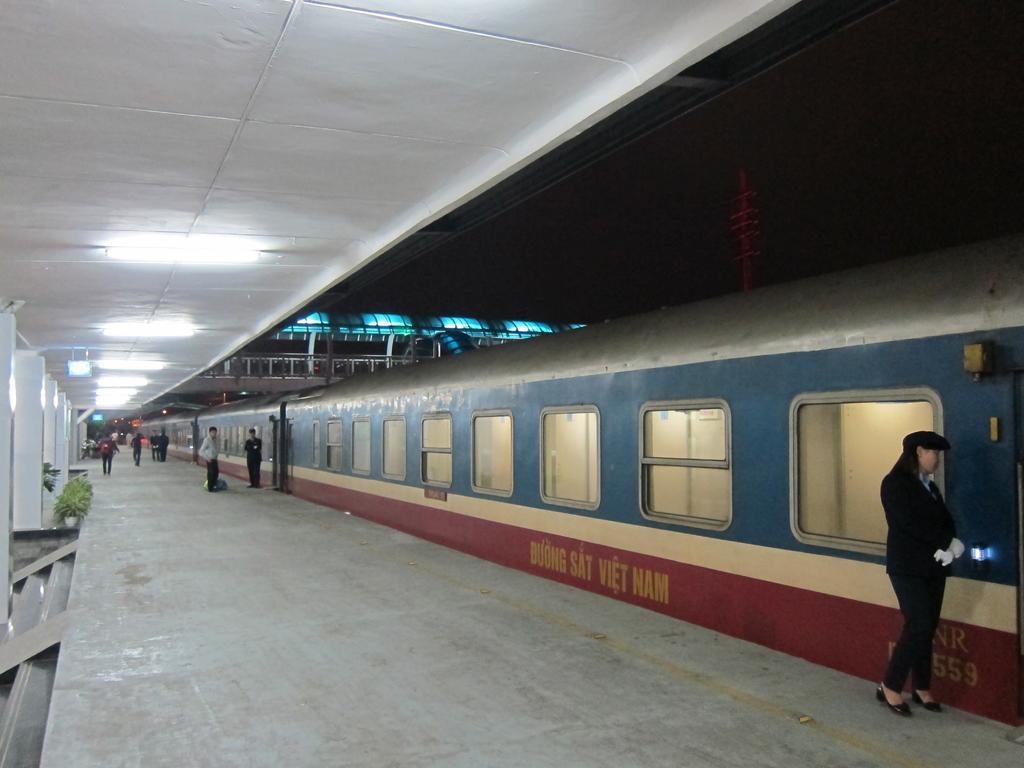Describe this image in one or two sentences. In this image we can see people are standing on the platform and train is there. At the top of the image white color roof is present. Left side of the image pillars and plants are there. 